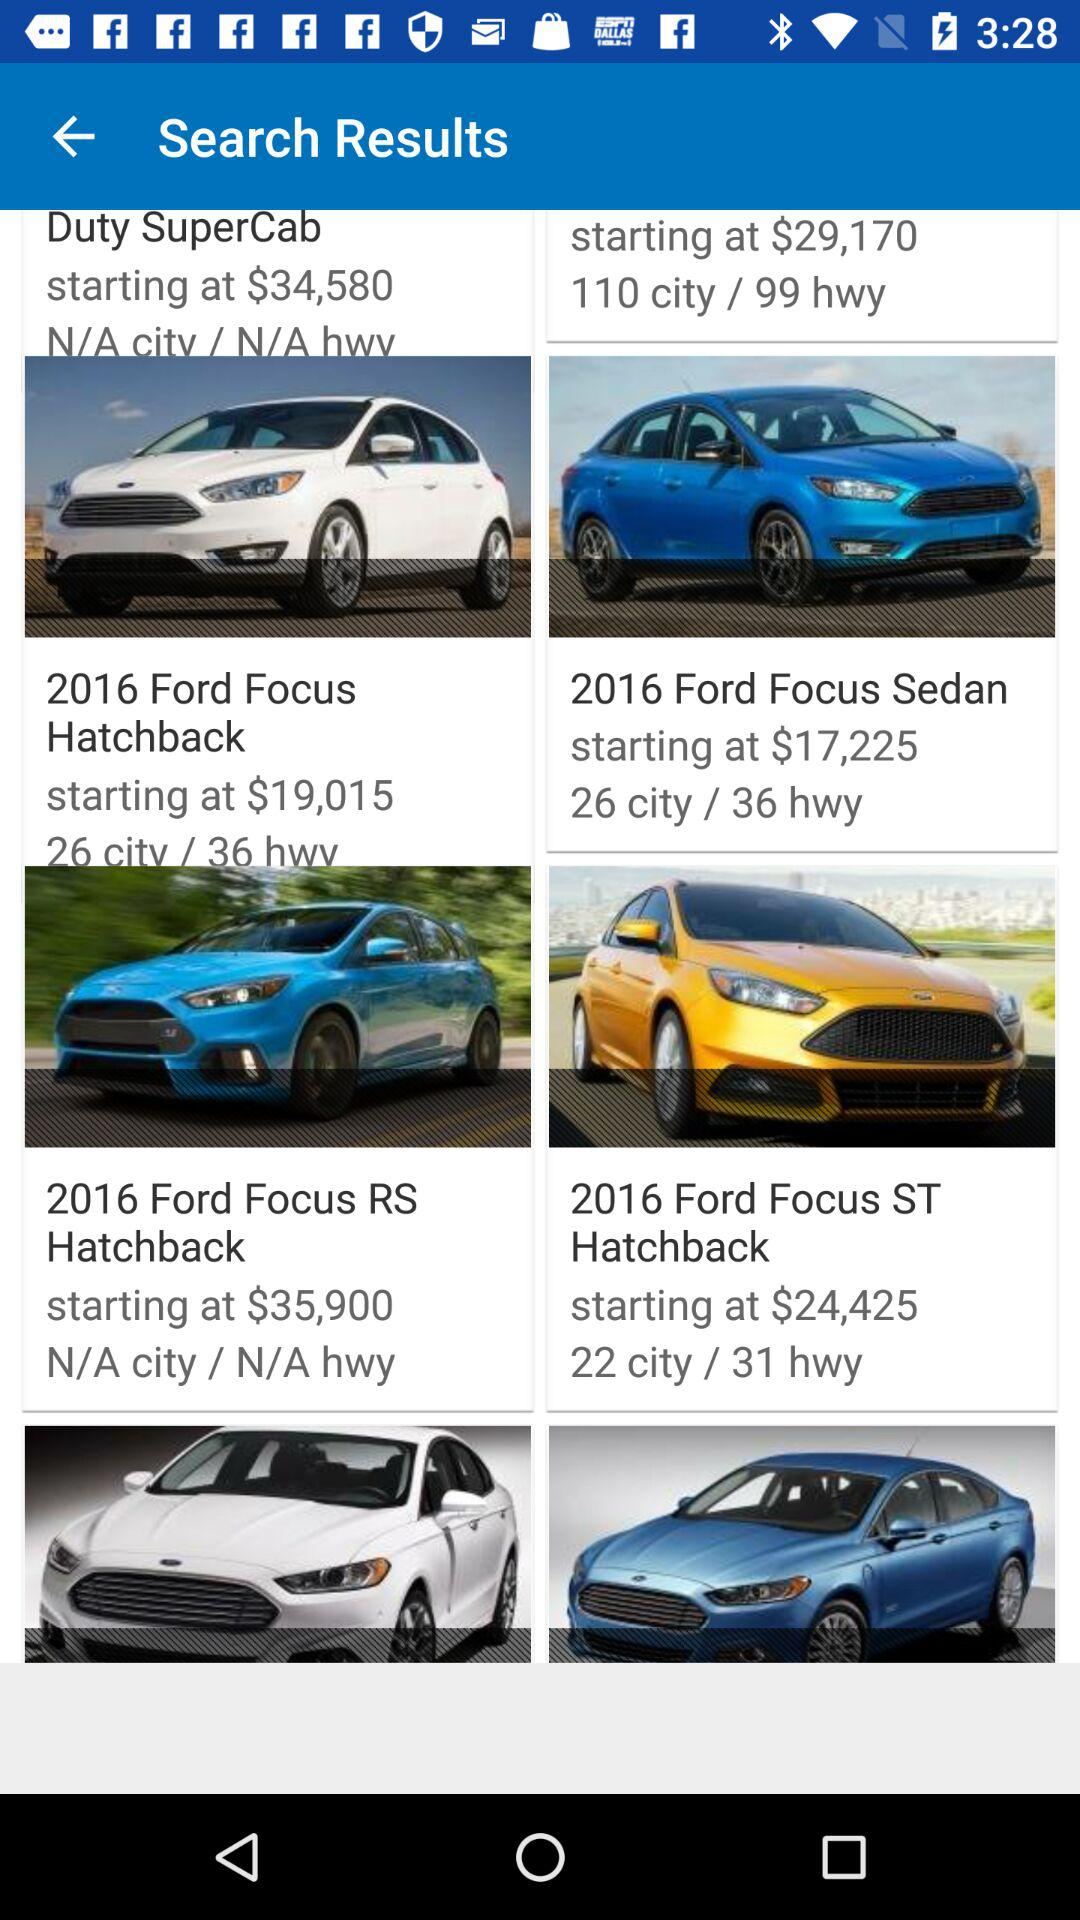What is the starting cost of the 2016 Ford Focus Hatchback? The starting cost is $19,015. 